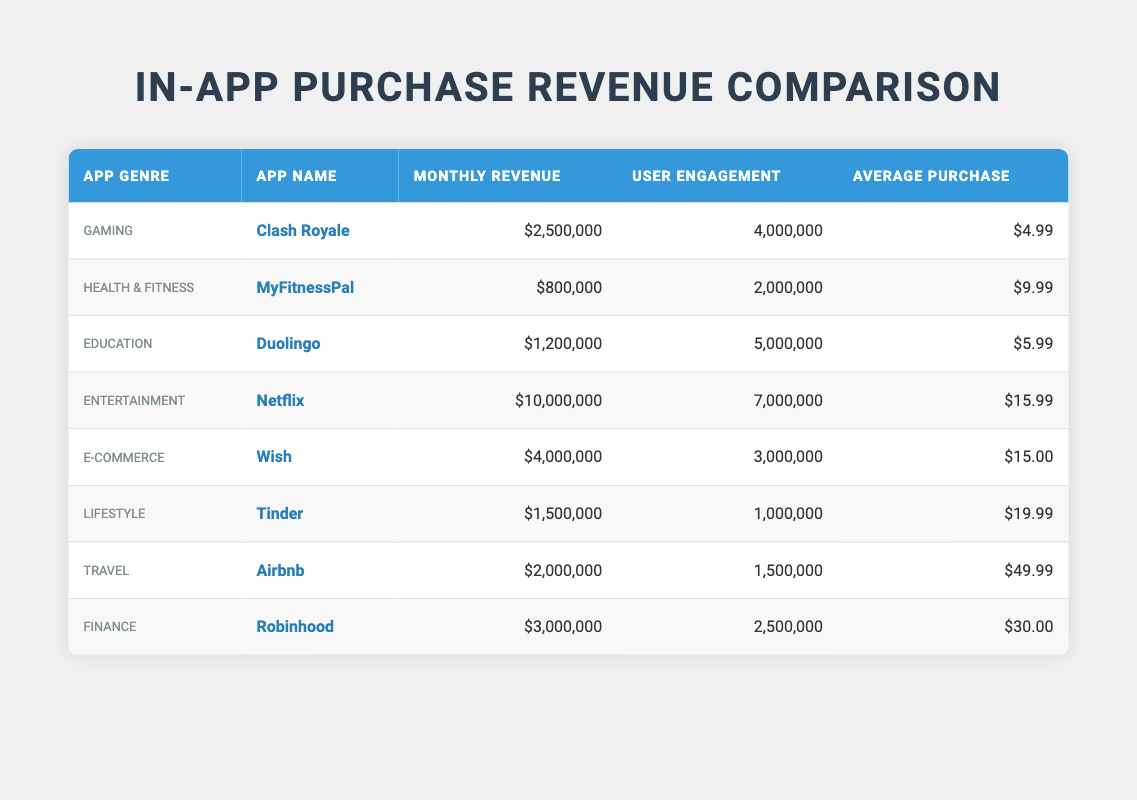What's the app with the highest monthly revenue? The table shows monthly revenues for each app; by comparing the values, Netflix has the highest monthly revenue of $10,000,000.
Answer: Netflix What is the average purchase amount for the Finance genre? The table shows Robinhood, which has an average purchase of $30.00, as the sole representative of the Finance genre in this data, so that is the average.
Answer: $30.00 Which genre had the lowest user engagement? By inspecting the user engagement values, Tinder has the lowest engagement with 1,000,000 users.
Answer: Lifestyle What is the total monthly revenue for the Gaming and Education genres combined? The monthly revenue for Gaming (Clash Royale) is $2,500,000 and for Education (Duolingo) it is $1,200,000. Adding these amounts gives $2,500,000 + $1,200,000 = $3,700,000.
Answer: $3,700,000 Is the average purchase amount for E-commerce greater than that for Health & Fitness? The average purchase for E-commerce (Wish) is $15.00, while that for Health & Fitness (MyFitnessPal) is $9.99. Since $15.00 is greater than $9.99, the statement is true.
Answer: Yes Which app from the table has the second highest user engagement? After sorting user engagement values, the app with the highest engagement is Netflix at 7,000,000; the second highest is Duolingo with 5,000,000 users.
Answer: Duolingo If you consider the average purchase for the top three apps by monthly revenue, what is the average? The top three apps by revenue are Netflix ($10,000,000 with $15.99), Wish ($4,000,000 with $15.00), and Clash Royale ($2,500,000 with $4.99). Adding the average purchases gives $15.99 + $15.00 + $4.99 = $35.98. Then divide by 3 to find the average: $35.98 / 3 = $11.99.
Answer: $11.99 Did any genre with over $1 million in monthly revenue have an average purchase below $10? Looking at the relevant genres, Health & Fitness ($9.99 average purchase) is above $1 million in revenue. The other genres with over $1 million in revenue have higher average purchases. Hence, there is one genre that meets this criterion.
Answer: Yes What is the ratio of user engagement for the Entertainment genre to that for the Health & Fitness genre? Engagement for Entertainment (Netflix) is 7,000,000 and for Health & Fitness (MyFitnessPal) it is 2,000,000. The ratio is computed as 7,000,000 / 2,000,000 which simplifies to 3.5.
Answer: 3.5 